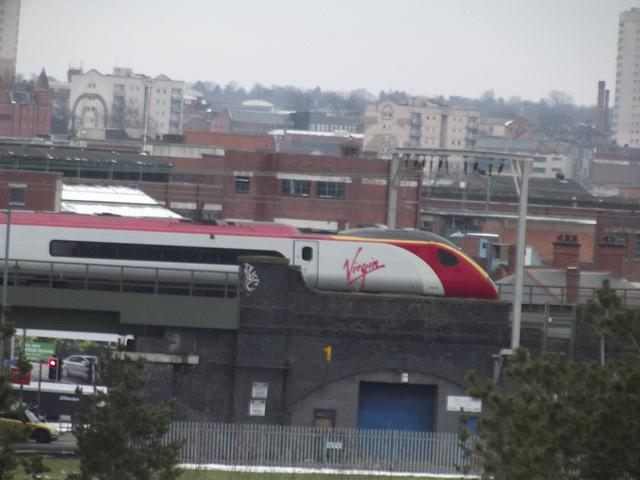The owners of this company first started it in which business? Please explain your reasoning. record. The company made records. 